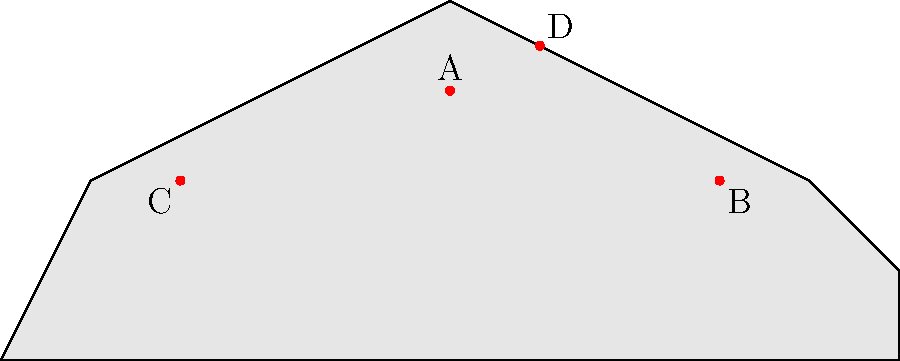As an eco-tourism enthusiast planning a trip to visit historical landmarks, identify which point on the map represents the Pyramids of Giza, an iconic ancient wonder known for its sustainable construction techniques and potential for eco-friendly tourism development. To answer this question, let's consider the characteristics of each point on the map and relate them to the Pyramids of Giza:

1. Point A: Located at the center of the map, which could represent a central location in the world. However, Egypt is not typically considered the center of the world map.

2. Point B: Positioned in the eastern part of the map, which doesn't align with Egypt's location relative to other continents.

3. Point C: Located in the western part of the map, which is closest to Egypt's actual location on a world map. The Pyramids of Giza are in Egypt, which is in the northeastern part of Africa, often appearing on the western side of standard world maps.

4. Point D: Positioned in the northern part of the map, which doesn't correspond to Egypt's location relative to other landmasses.

Given these considerations, Point C is the most likely representation of the Pyramids of Giza on this simplified world map. It aligns with Egypt's general location on a typical world map projection.

The Pyramids of Giza are indeed an excellent choice for eco-tourism enthusiasts interested in historical landmarks. They showcase ancient sustainable construction techniques and have potential for eco-friendly tourism development, aligning with the interests of the specified persona.
Answer: Point C 